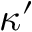<formula> <loc_0><loc_0><loc_500><loc_500>\kappa ^ { \prime }</formula> 